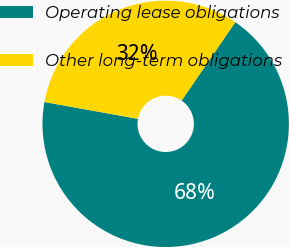<chart> <loc_0><loc_0><loc_500><loc_500><pie_chart><fcel>Operating lease obligations<fcel>Other long-term obligations<nl><fcel>68.28%<fcel>31.72%<nl></chart> 